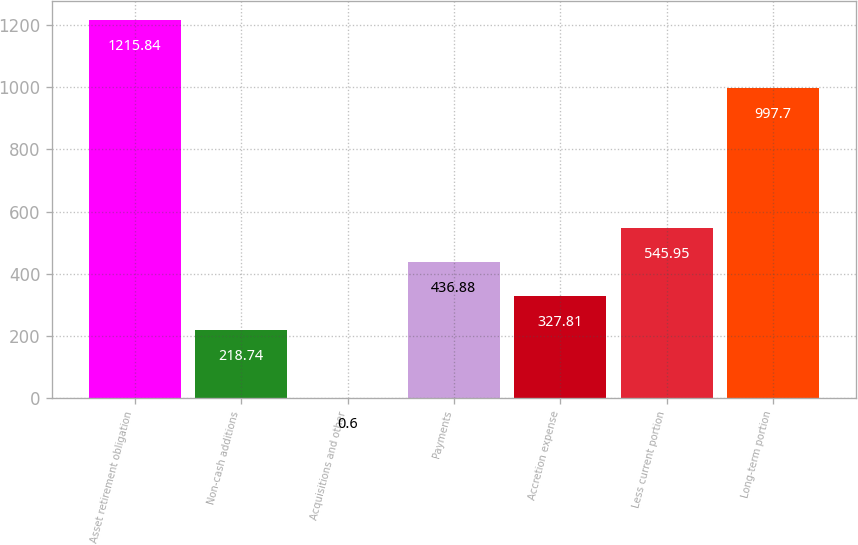Convert chart to OTSL. <chart><loc_0><loc_0><loc_500><loc_500><bar_chart><fcel>Asset retirement obligation<fcel>Non-cash additions<fcel>Acquisitions and other<fcel>Payments<fcel>Accretion expense<fcel>Less current portion<fcel>Long-term portion<nl><fcel>1215.84<fcel>218.74<fcel>0.6<fcel>436.88<fcel>327.81<fcel>545.95<fcel>997.7<nl></chart> 